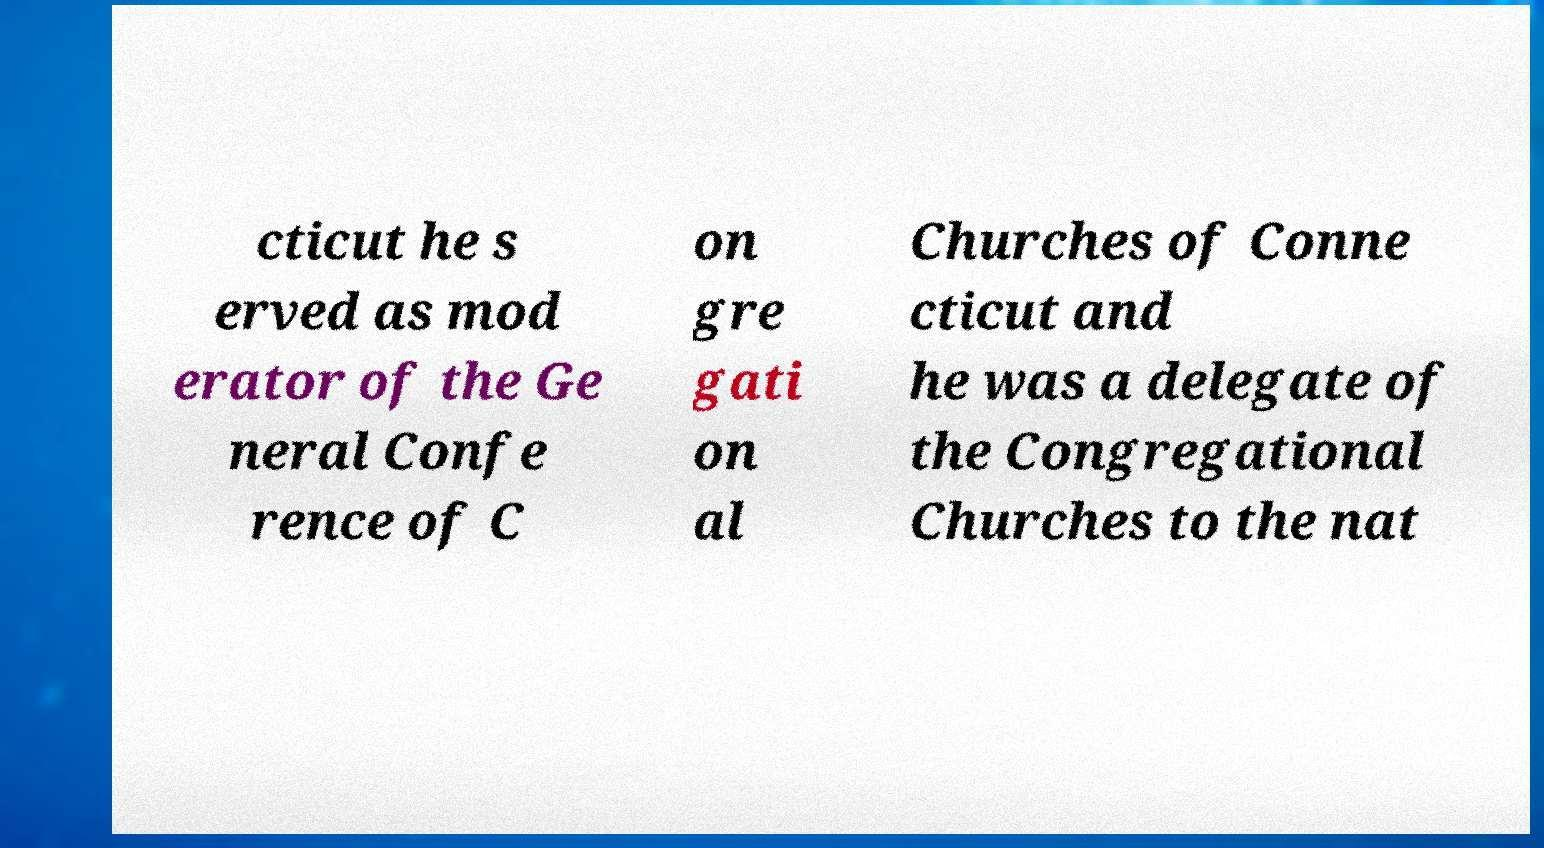Please read and relay the text visible in this image. What does it say? cticut he s erved as mod erator of the Ge neral Confe rence of C on gre gati on al Churches of Conne cticut and he was a delegate of the Congregational Churches to the nat 